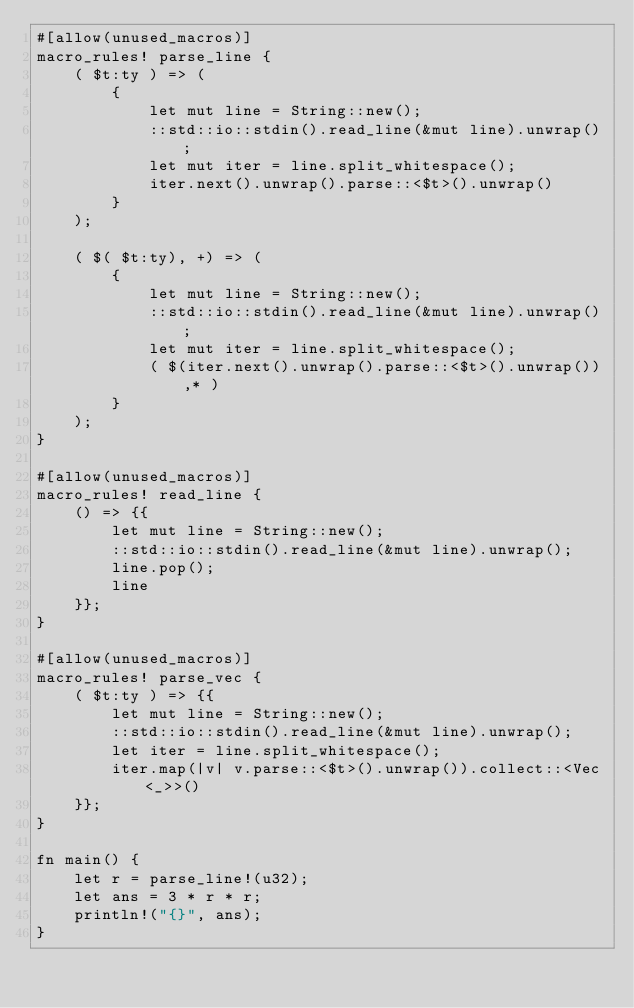Convert code to text. <code><loc_0><loc_0><loc_500><loc_500><_Rust_>#[allow(unused_macros)]
macro_rules! parse_line {
    ( $t:ty ) => (
        {
            let mut line = String::new();
            ::std::io::stdin().read_line(&mut line).unwrap();
            let mut iter = line.split_whitespace();
            iter.next().unwrap().parse::<$t>().unwrap()
        }
    );

    ( $( $t:ty), +) => (
        {
            let mut line = String::new();
            ::std::io::stdin().read_line(&mut line).unwrap();
            let mut iter = line.split_whitespace();
            ( $(iter.next().unwrap().parse::<$t>().unwrap()),* )
        }
    );
}

#[allow(unused_macros)]
macro_rules! read_line {
    () => {{
        let mut line = String::new();
        ::std::io::stdin().read_line(&mut line).unwrap();
        line.pop();
        line
    }};
}

#[allow(unused_macros)]
macro_rules! parse_vec {
    ( $t:ty ) => {{
        let mut line = String::new();
        ::std::io::stdin().read_line(&mut line).unwrap();
        let iter = line.split_whitespace();
        iter.map(|v| v.parse::<$t>().unwrap()).collect::<Vec<_>>()
    }};
}

fn main() {
    let r = parse_line!(u32);
    let ans = 3 * r * r;
    println!("{}", ans);
}
</code> 